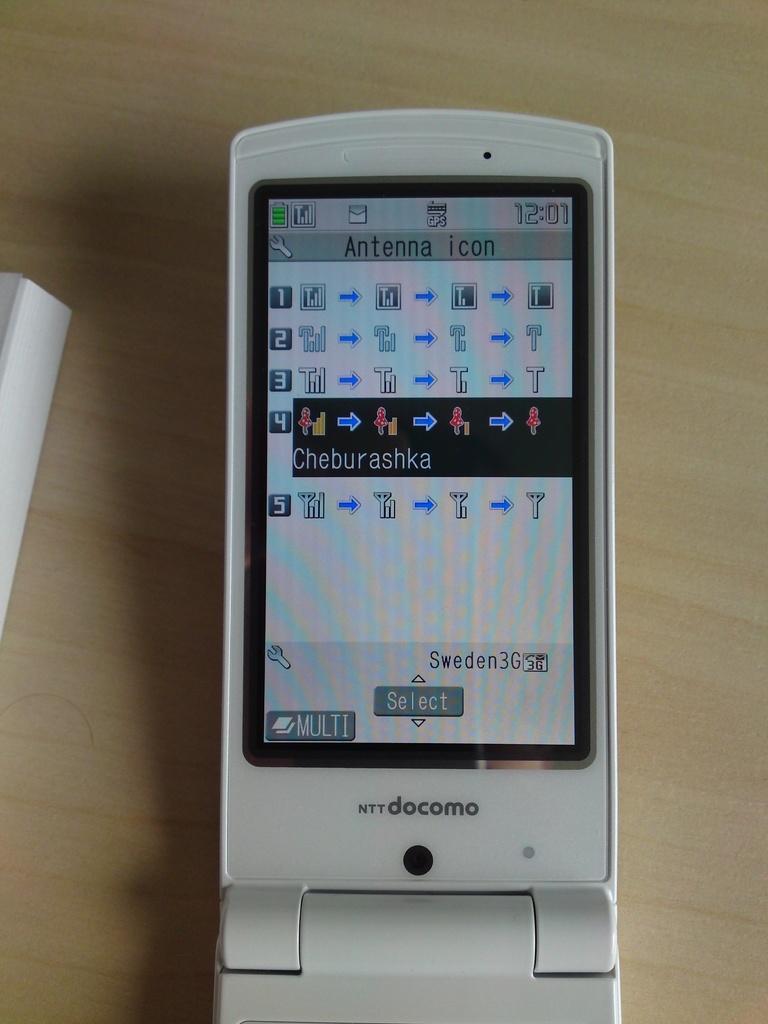How would you summarize this image in a sentence or two? In this image I can see a mobile and an object is on the wooden surface. 